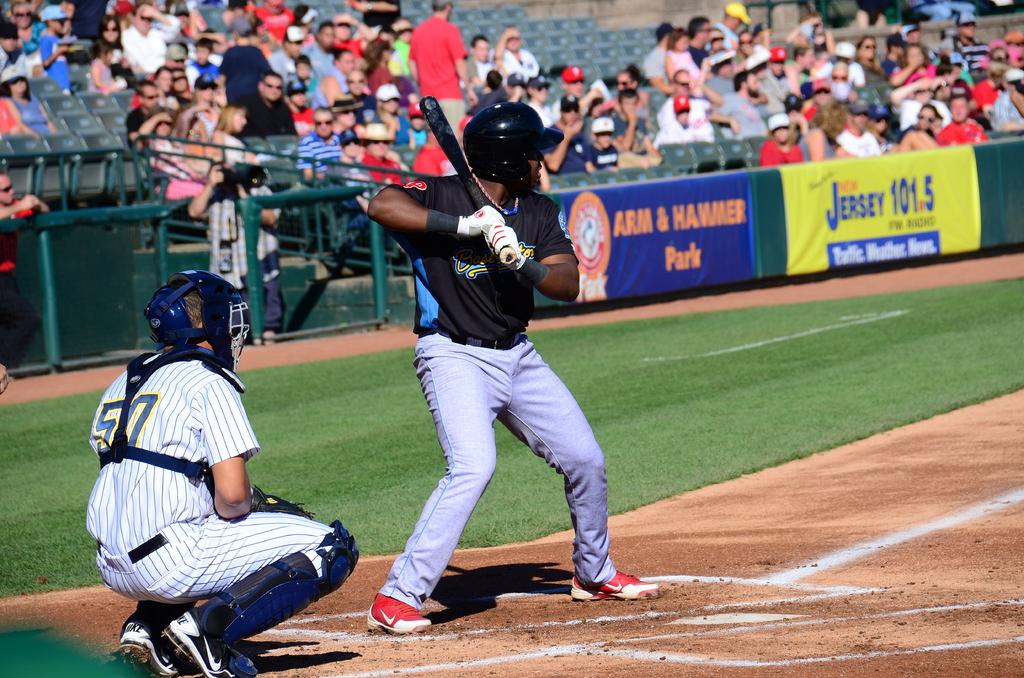What is the name of the station on the advertisers board?
Provide a succinct answer. Jersey 101.5. 